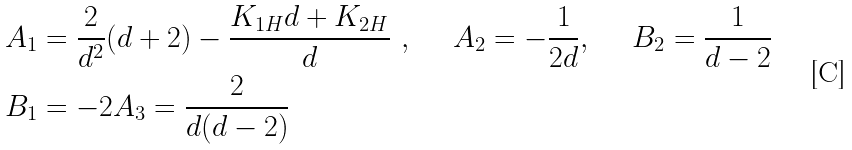Convert formula to latex. <formula><loc_0><loc_0><loc_500><loc_500>A _ { 1 } & = \frac { 2 } { d ^ { 2 } } ( d + 2 ) - \frac { K _ { 1 H } d + K _ { 2 H } } { d } \ , \quad \ A _ { 2 } = - \frac { 1 } { 2 d } , \quad \ B _ { 2 } = \frac { 1 } { d - 2 } \\ B _ { 1 } & = - 2 A _ { 3 } = \frac { 2 } { d ( d - 2 ) }</formula> 